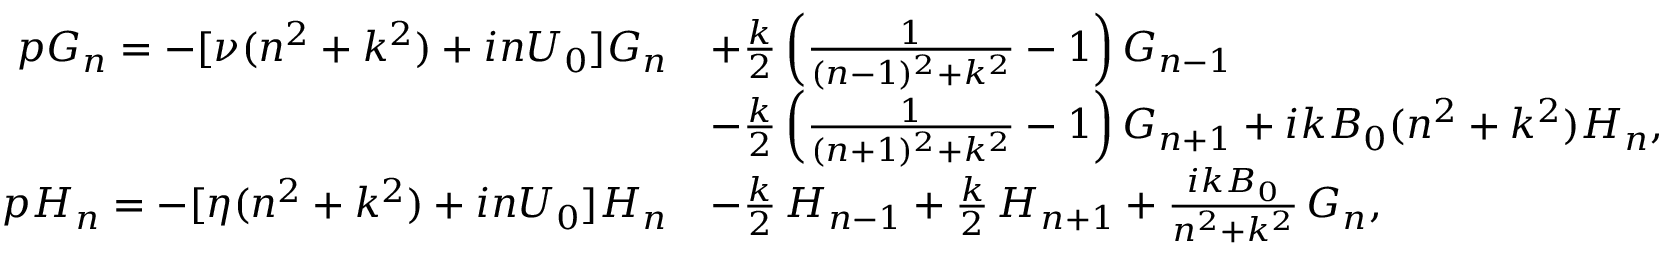<formula> <loc_0><loc_0><loc_500><loc_500>\begin{array} { r l } { p G _ { n } = - [ \nu ( n ^ { 2 } + k ^ { 2 } ) + i n U _ { 0 } ] G _ { n } } & { + \frac { k } { 2 } \left ( \frac { 1 } { ( n - 1 ) ^ { 2 } + k ^ { 2 } } - 1 \right ) G _ { n - 1 } } \\ & { - \frac { k } { 2 } \left ( \frac { 1 } { ( n + 1 ) ^ { 2 } + k ^ { 2 } } - 1 \right ) G _ { n + 1 } + i k B _ { 0 } ( n ^ { 2 } + k ^ { 2 } ) H _ { n } , } \\ { p H _ { n } = - [ \eta ( n ^ { 2 } + k ^ { 2 } ) + i n U _ { 0 } ] H _ { n } } & { - \frac { k } { 2 } \, H _ { n - 1 } + \frac { k } { 2 } \, H _ { n + 1 } + \frac { i k B _ { 0 } } { n ^ { 2 } + k ^ { 2 } } \, G _ { n } , } \end{array}</formula> 